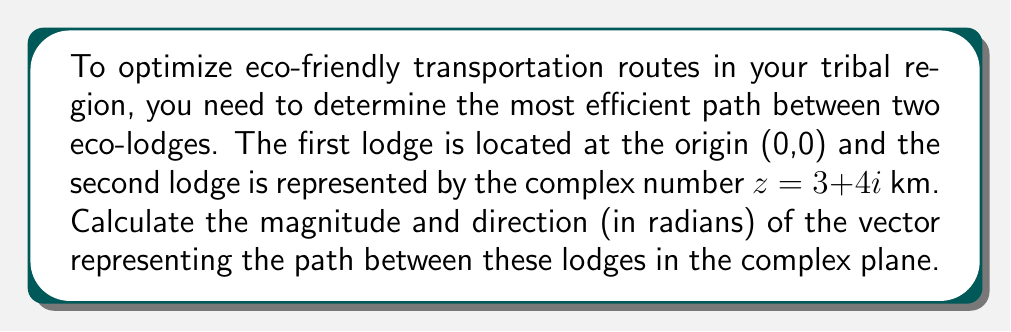Show me your answer to this math problem. To solve this problem, we need to determine the magnitude and direction of the complex number $z = 3 + 4i$.

1. Magnitude calculation:
   The magnitude of a complex number $z = a + bi$ is given by $|z| = \sqrt{a^2 + b^2}$.
   In this case, $|z| = \sqrt{3^2 + 4^2} = \sqrt{9 + 16} = \sqrt{25} = 5$ km.

2. Direction calculation:
   The direction of a complex number is given by its argument, $\arg(z)$, which can be calculated using the arctangent function:
   $$\arg(z) = \tan^{-1}\left(\frac{b}{a}\right)$$
   Where $a$ is the real part and $b$ is the imaginary part.

   $$\arg(z) = \tan^{-1}\left(\frac{4}{3}\right) \approx 0.9273$ radians$$

To visualize this:

[asy]
import graph;
size(200);
real f(real x) {return 4/3*x;}
xaxis("Real",Arrow);
yaxis("Imaginary",Arrow);
draw((0,0)--(3,4),Arrow);
draw((0,0)--(3,0),dashed);
draw((3,0)--(3,4),dashed);
label("3",(1.5,0),S);
label("4",(3,2),E);
label("5",(1.5,2),NW);
label("θ",(0.5,0.2),NE);
dot((0,0));
dot((3,4));
[/asy]

The magnitude represents the direct distance between the two eco-lodges, while the direction indicates the angle of the path relative to the positive real axis.
Answer: Magnitude: 5 km, Direction: 0.9273 radians 